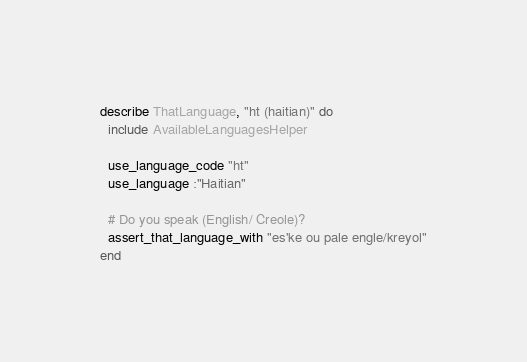<code> <loc_0><loc_0><loc_500><loc_500><_Ruby_>
describe ThatLanguage, "ht (haitian)" do
  include AvailableLanguagesHelper

  use_language_code "ht"
  use_language :"Haitian"

  # Do you speak (English/ Creole)?
  assert_that_language_with "es'ke ou pale engle/kreyol"
end
</code> 